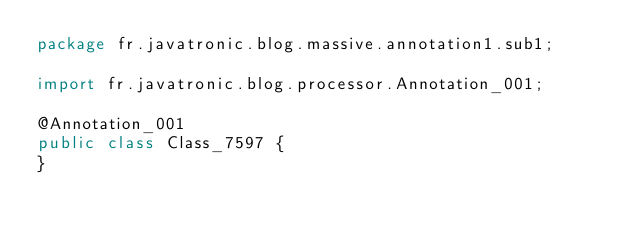<code> <loc_0><loc_0><loc_500><loc_500><_Java_>package fr.javatronic.blog.massive.annotation1.sub1;

import fr.javatronic.blog.processor.Annotation_001;

@Annotation_001
public class Class_7597 {
}
</code> 